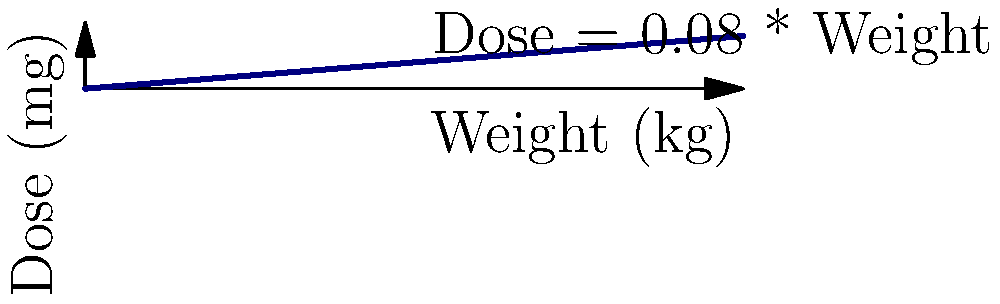Using the nomogram provided, calculate the appropriate drug dosage for a patient weighing 75 kg. Round your answer to the nearest tenth of a milligram. To determine the drug dosage using the nomogram:

1. Locate the patient's weight (75 kg) on the x-axis.
2. Move vertically from this point until you intersect the dosage line.
3. From the intersection point, move horizontally to the y-axis to read the corresponding dose.

We can also calculate this mathematically:

The nomogram shows a linear relationship between weight and dose, represented by the equation:

$$ \text{Dose (mg)} = 0.08 \times \text{Weight (kg)} $$

For a patient weighing 75 kg:

$$ \text{Dose} = 0.08 \times 75 = 6 \text{ mg} $$

Therefore, the appropriate drug dosage for a patient weighing 75 kg is 6.0 mg.
Answer: 6.0 mg 